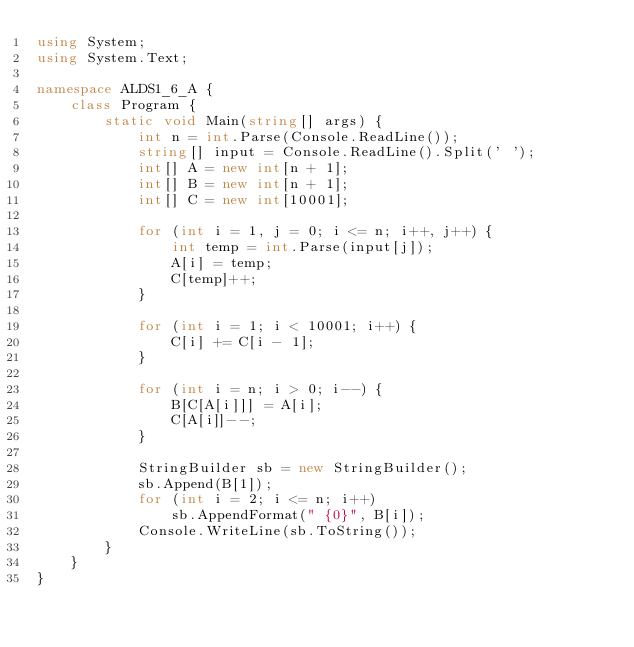<code> <loc_0><loc_0><loc_500><loc_500><_C#_>using System;
using System.Text;

namespace ALDS1_6_A {
    class Program {
        static void Main(string[] args) {
            int n = int.Parse(Console.ReadLine());
            string[] input = Console.ReadLine().Split(' ');
            int[] A = new int[n + 1];
            int[] B = new int[n + 1];
            int[] C = new int[10001];

            for (int i = 1, j = 0; i <= n; i++, j++) {
                int temp = int.Parse(input[j]);
                A[i] = temp;
                C[temp]++;
            }

            for (int i = 1; i < 10001; i++) {
                C[i] += C[i - 1];
            }

            for (int i = n; i > 0; i--) {
                B[C[A[i]]] = A[i];
                C[A[i]]--;
            }

            StringBuilder sb = new StringBuilder();
            sb.Append(B[1]);
            for (int i = 2; i <= n; i++)
                sb.AppendFormat(" {0}", B[i]);
            Console.WriteLine(sb.ToString());
        }
    }
}</code> 